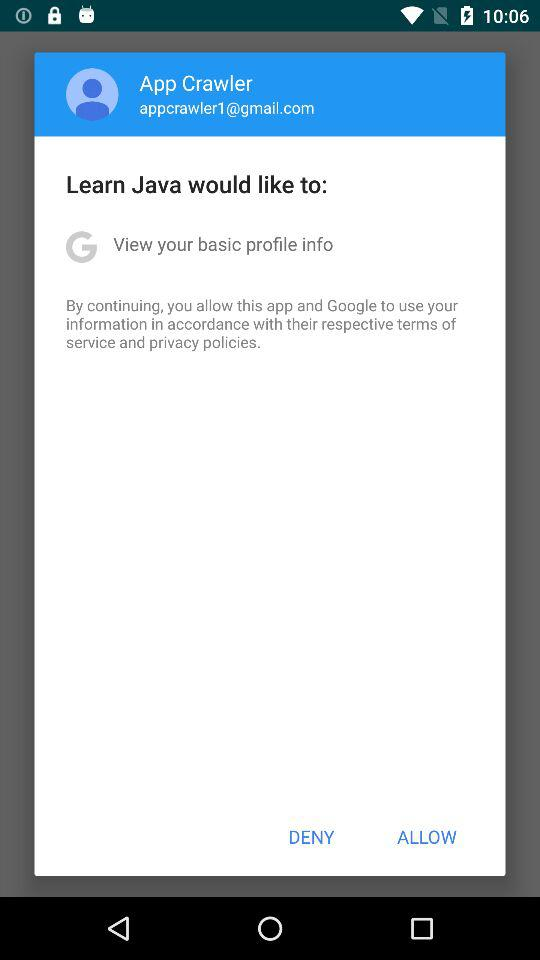What is the email address? The email address is appcrawler1@gmail.com. 